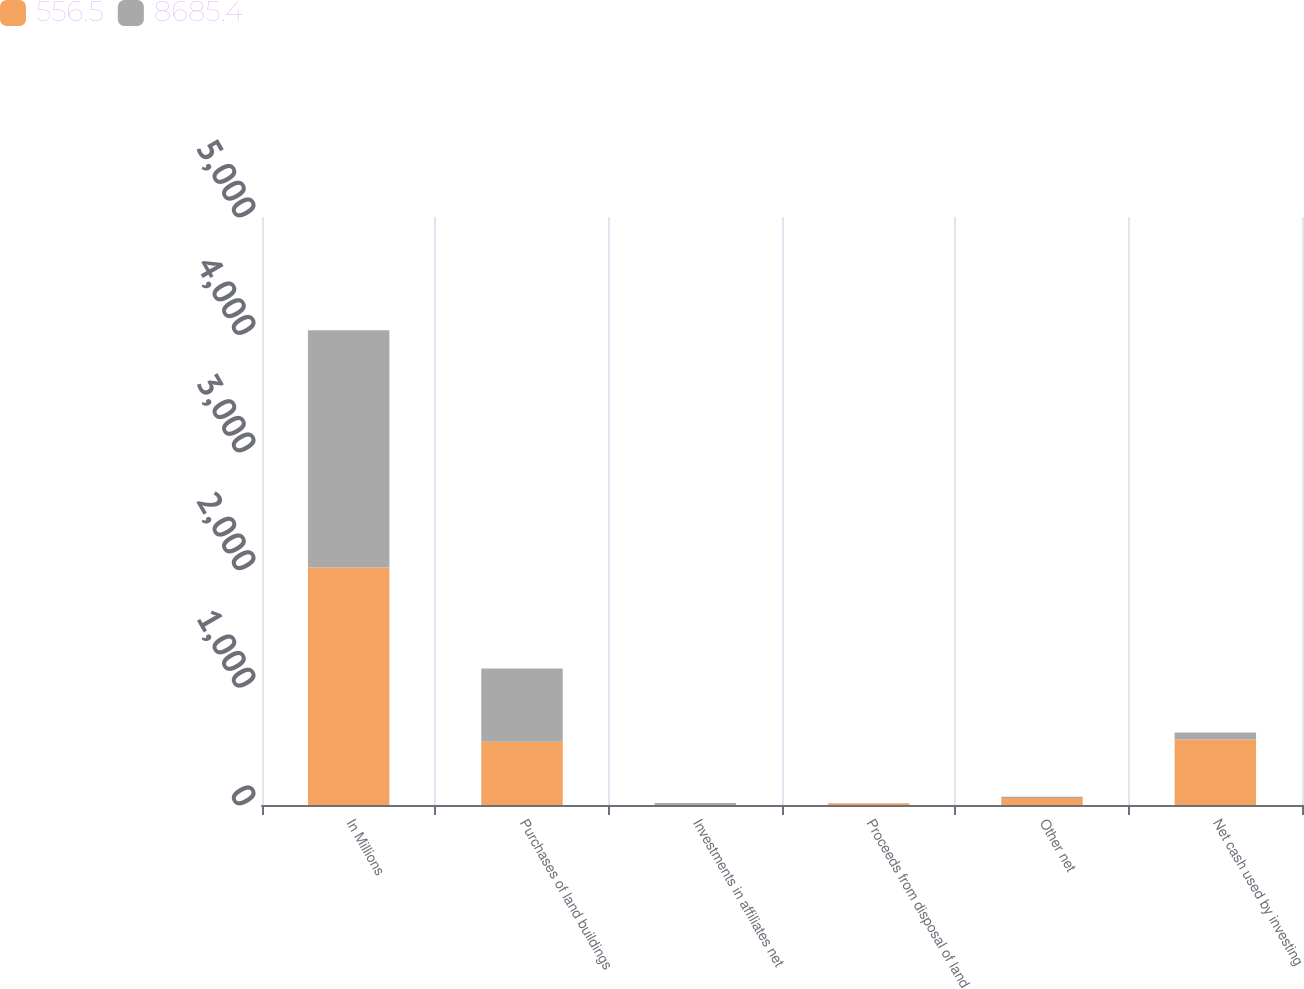Convert chart. <chart><loc_0><loc_0><loc_500><loc_500><stacked_bar_chart><ecel><fcel>In Millions<fcel>Purchases of land buildings<fcel>Investments in affiliates net<fcel>Proceeds from disposal of land<fcel>Other net<fcel>Net cash used by investing<nl><fcel>556.5<fcel>2019<fcel>537.6<fcel>0.1<fcel>14.3<fcel>59.7<fcel>556.5<nl><fcel>8685.4<fcel>2018<fcel>622.7<fcel>17.3<fcel>1.4<fcel>11<fcel>59.7<nl></chart> 